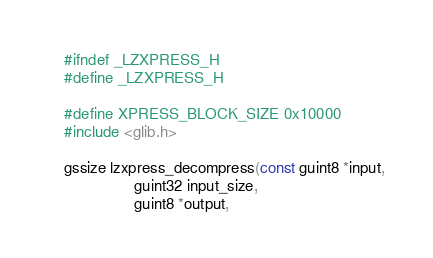<code> <loc_0><loc_0><loc_500><loc_500><_C_>
#ifndef _LZXPRESS_H
#define _LZXPRESS_H

#define XPRESS_BLOCK_SIZE 0x10000
#include <glib.h>

gssize lzxpress_decompress(const guint8 *input,
			    guint32 input_size,
			    guint8 *output,</code> 